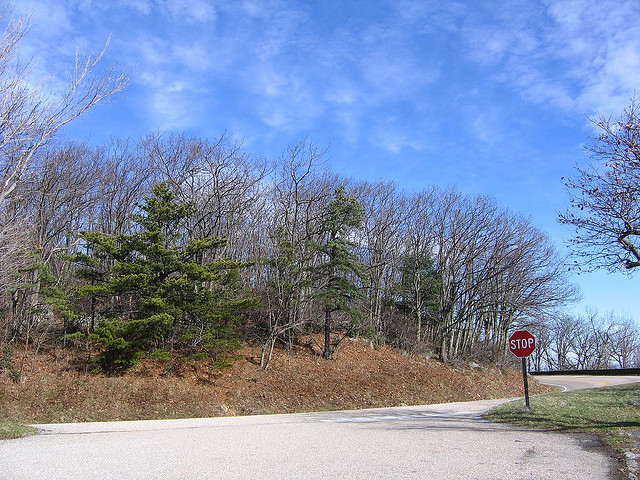Where is the photographer standing? The photographer appears to be standing on the side of a paved road adjacent to the stop sign. 